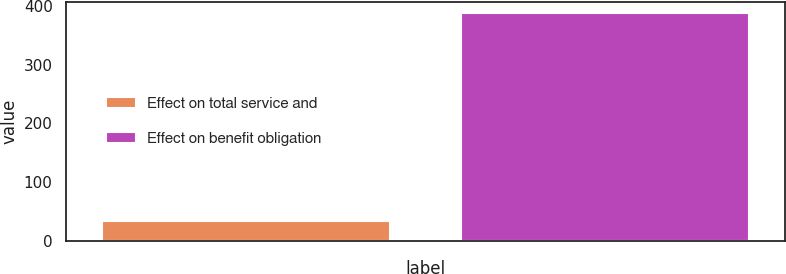Convert chart. <chart><loc_0><loc_0><loc_500><loc_500><bar_chart><fcel>Effect on total service and<fcel>Effect on benefit obligation<nl><fcel>33.5<fcel>387.9<nl></chart> 